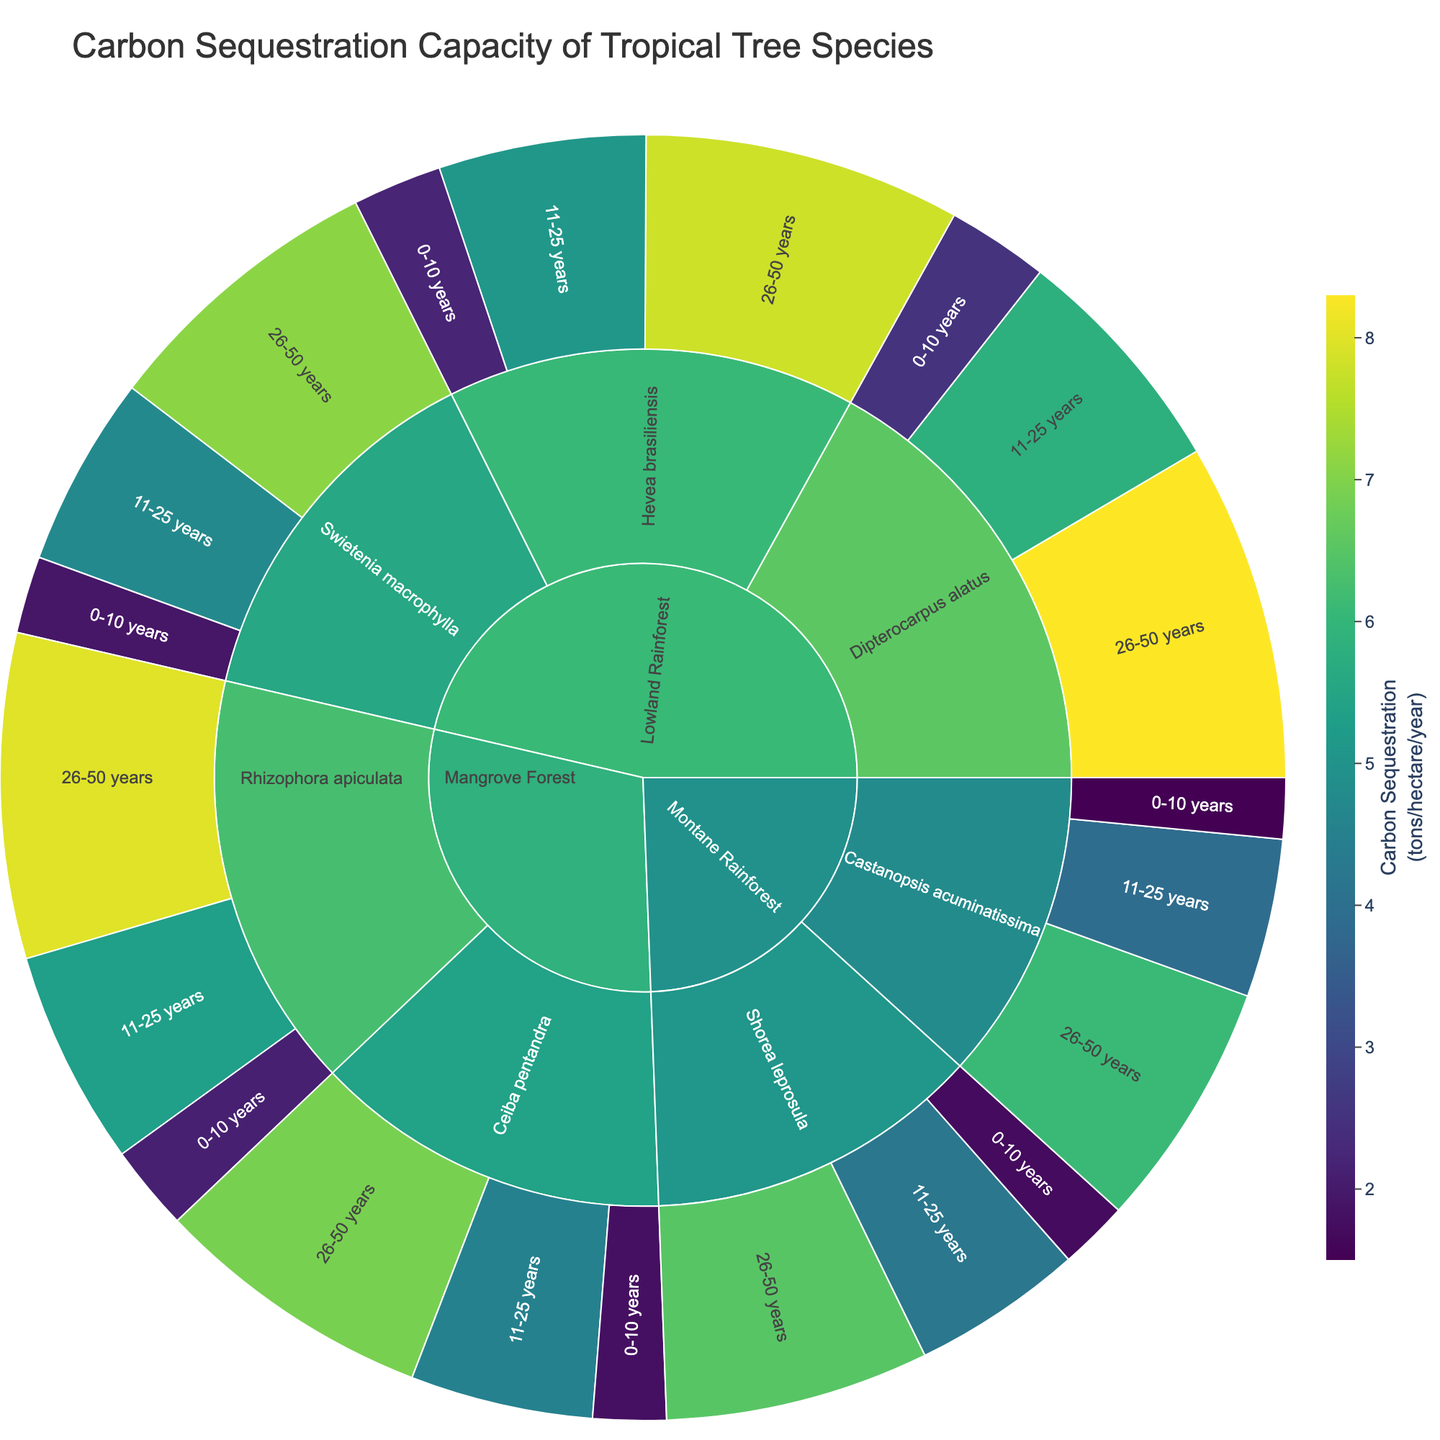What's the title of the sunburst plot? The title is located at the top of the sunburst plot. It provides a brief description of what the plot represents.
Answer: Carbon Sequestration Capacity of Tropical Tree Species Which tree species has the highest carbon sequestration in the Lowland Rainforest for the age group 26-50 years? Locate the Lowland Rainforest section, then identify the section for the 26-50 years age group. Compare the carbon sequestration values within this group.
Answer: Dipterocarpus alatus What is the total carbon sequestration for Hevea brasiliensis in the Lowland Rainforest summing across all age groups? Locate Hevea brasiliensis in the Lowland Rainforest section and sum up the carbon sequestration values for all age groups: 2.2 + 5.1 + 7.8.
Answer: 15.1 tons/hectare/year For Rhizophora apiculata in the Mangrove Forest, how does the carbon sequestration in the 11-25 years age group compare to the 0-10 years age group? Identify the carbon sequestration values for Rhizophora apiculata in the Mangrove Forest for the age groups 0-10 years and 11-25 years. Compare 5.3 with 2.1 and observe the difference.
Answer: Greater in 11-25 years Which tree species in the Montane Rainforest shows the biggest difference in carbon sequestration between the 11-25 years and 26-50 years age groups? Evaluate the difference in carbon sequestration between the age groups 11-25 years and 26-50 years for each tree species in the Montane Rainforest. Shorea leprosula: 6.5 - 4.2 = 2.3, Castanopsis acuminatissima: 6.1 - 3.9 = 2.2. The largest difference is for Shorea leprosula.
Answer: Shorea leprosula What's the combined carbon sequestration of Swietenia macrophylla in the Lowland Rainforest for the age groups 0-10 and 11-25 years? Add the carbon sequestration values for Swietenia macrophylla in the Lowland Rainforest for the 0-10 years and 11-25 years age groups: 1.9 + 4.7.
Answer: 6.6 tons/hectare/year Which tree species in the Mangrove Forest has the highest carbon sequestration in any individual age group? Identify the maximum carbon sequestration value for each tree species in the Mangrove Forest and compare them. Rhizophora apiculata (8.0) has the highest value compared to Ceiba pentandra (6.9).
Answer: Rhizophora apiculata 